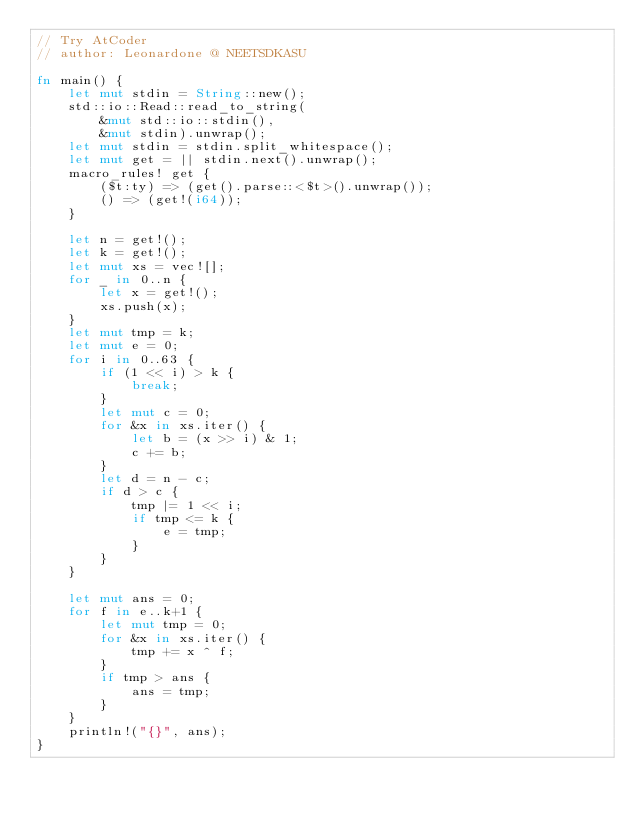<code> <loc_0><loc_0><loc_500><loc_500><_Rust_>// Try AtCoder
// author: Leonardone @ NEETSDKASU

fn main() {
	let mut stdin = String::new();
    std::io::Read::read_to_string(
    	&mut std::io::stdin(),
        &mut stdin).unwrap();
	let mut stdin = stdin.split_whitespace();
    let mut get = || stdin.next().unwrap();
    macro_rules! get {
    	($t:ty) => (get().parse::<$t>().unwrap());
        () => (get!(i64));
    }
    
    let n = get!();
    let k = get!();
    let mut xs = vec![];
    for _ in 0..n {
    	let x = get!();
        xs.push(x);
    }
    let mut tmp = k;
    let mut e = 0;
    for i in 0..63 {
    	if (1 << i) > k {
        	break;
        }
    	let mut c = 0;
    	for &x in xs.iter() {
        	let b = (x >> i) & 1;
            c += b;
        }
        let d = n - c;
        if d > c {
        	tmp |= 1 << i;
            if tmp <= k {
            	e = tmp;
            }
        }
    }

    let mut ans = 0;
	for f in e..k+1 {
		let mut tmp = 0;
        for &x in xs.iter() {
        	tmp += x ^ f;
		}
        if tmp > ans {
        	ans = tmp;
        }
	}
    println!("{}", ans);
}</code> 